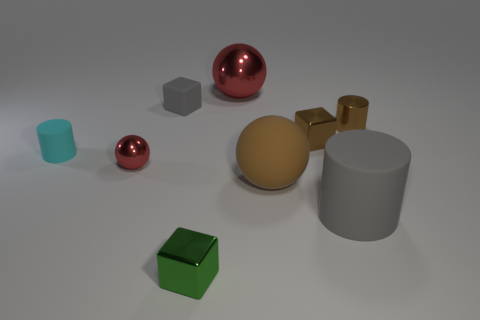Subtract all brown metal cylinders. How many cylinders are left? 2 Subtract all gray cylinders. How many red spheres are left? 2 Subtract 1 blocks. How many blocks are left? 2 Subtract all cubes. How many objects are left? 6 Add 9 big red objects. How many big red objects exist? 10 Subtract 1 brown cubes. How many objects are left? 8 Subtract all purple cylinders. Subtract all gray cubes. How many cylinders are left? 3 Subtract all big red objects. Subtract all small brown blocks. How many objects are left? 7 Add 1 gray rubber cylinders. How many gray rubber cylinders are left? 2 